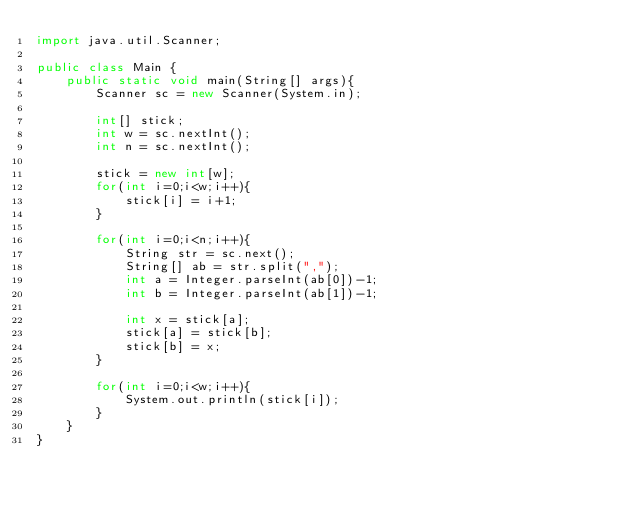<code> <loc_0><loc_0><loc_500><loc_500><_Java_>import java.util.Scanner;

public class Main {
    public static void main(String[] args){
        Scanner sc = new Scanner(System.in);

        int[] stick;
        int w = sc.nextInt();
        int n = sc.nextInt();

        stick = new int[w];
        for(int i=0;i<w;i++){
            stick[i] = i+1;
        }

        for(int i=0;i<n;i++){
            String str = sc.next();
            String[] ab = str.split(",");
            int a = Integer.parseInt(ab[0])-1;
            int b = Integer.parseInt(ab[1])-1;

            int x = stick[a];
            stick[a] = stick[b];
            stick[b] = x;
        }

        for(int i=0;i<w;i++){
            System.out.println(stick[i]);
        }
    }
}

</code> 